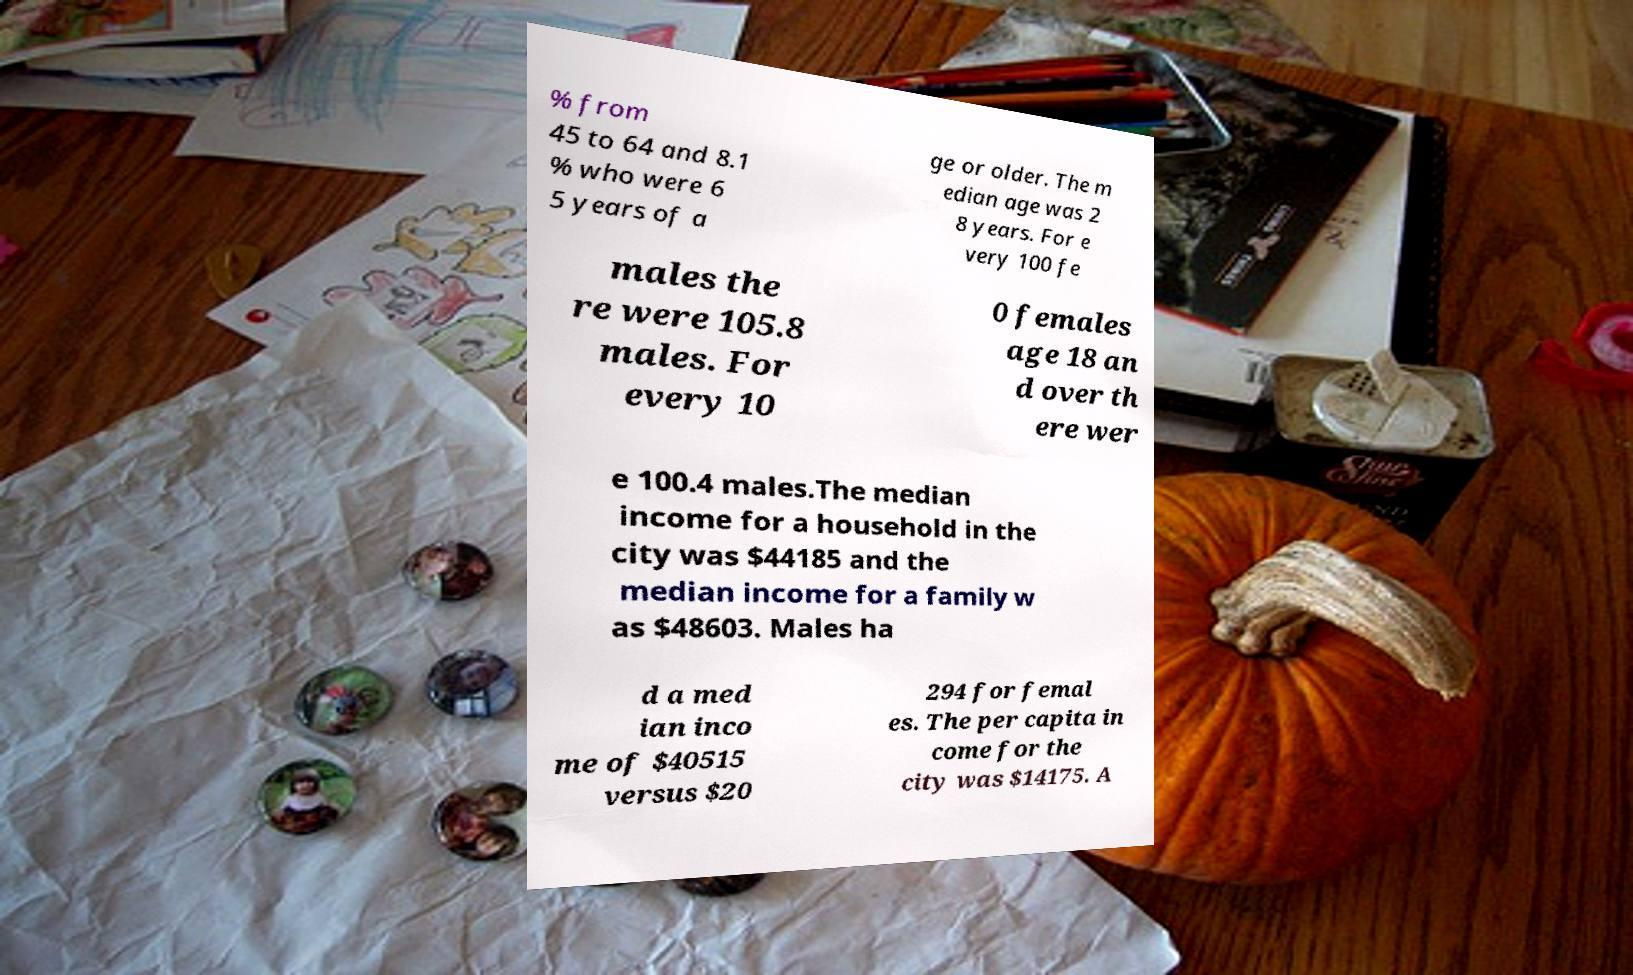I need the written content from this picture converted into text. Can you do that? % from 45 to 64 and 8.1 % who were 6 5 years of a ge or older. The m edian age was 2 8 years. For e very 100 fe males the re were 105.8 males. For every 10 0 females age 18 an d over th ere wer e 100.4 males.The median income for a household in the city was $44185 and the median income for a family w as $48603. Males ha d a med ian inco me of $40515 versus $20 294 for femal es. The per capita in come for the city was $14175. A 